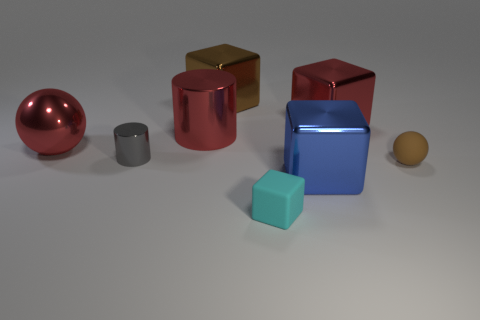Subtract all blue blocks. How many blocks are left? 3 Add 1 big metallic cylinders. How many objects exist? 9 Subtract all cylinders. How many objects are left? 6 Subtract all purple cubes. How many cyan cylinders are left? 0 Subtract all small cyan metallic cubes. Subtract all small gray cylinders. How many objects are left? 7 Add 2 balls. How many balls are left? 4 Add 8 small red cubes. How many small red cubes exist? 8 Subtract all red blocks. How many blocks are left? 3 Subtract 1 red cylinders. How many objects are left? 7 Subtract 2 spheres. How many spheres are left? 0 